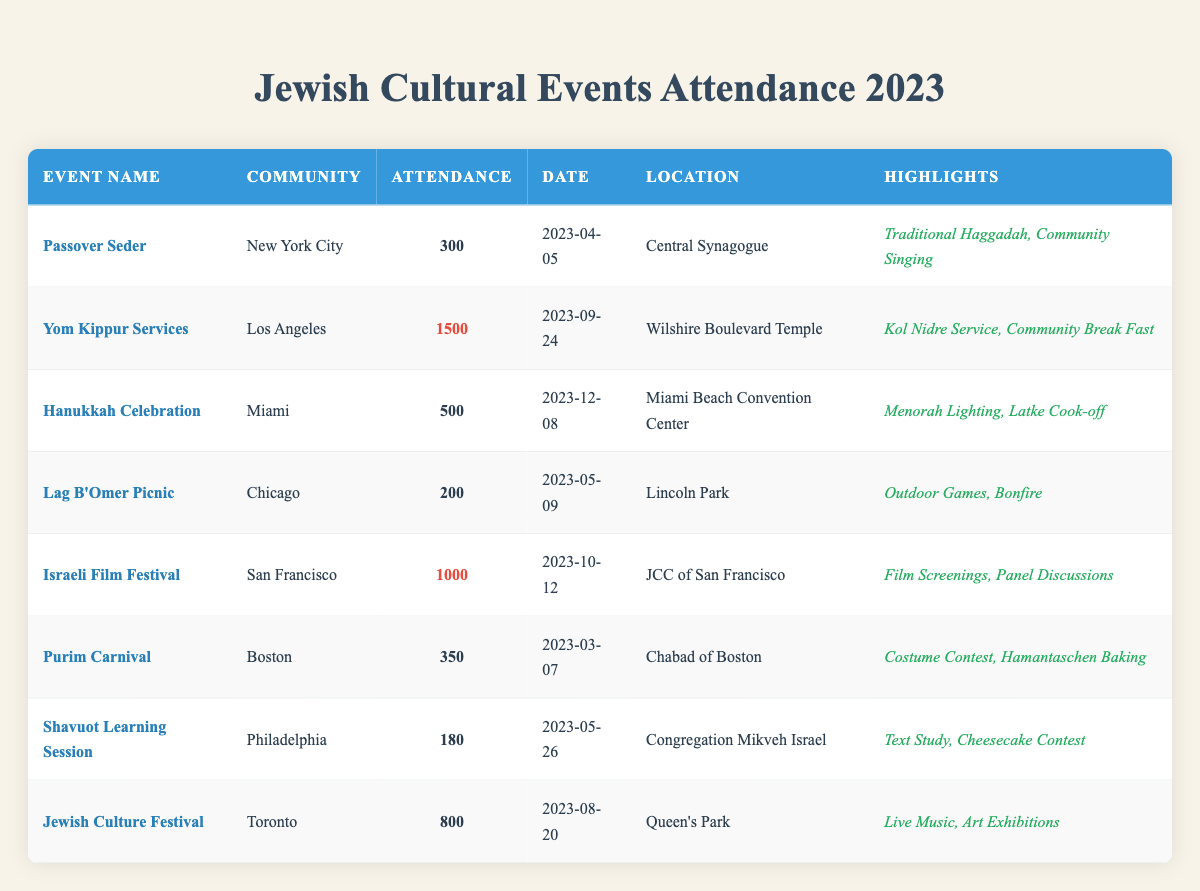What was the attendance for the Yom Kippur Services? The table shows that the attendance for the Yom Kippur Services held in Los Angeles was 1500.
Answer: 1500 Which community had the lowest attendance at a cultural event? By comparing the attendance numbers across all events, the Lag B'Omer Picnic in Chicago had the lowest at 200.
Answer: Chicago What is the total attendance for all events listed? The total attendance can be calculated by adding all attendance figures: 300 + 1500 + 500 + 200 + 1000 + 350 + 180 + 800 = 3830.
Answer: 3830 How many events had an attendance of more than 600? The events with attendance over 600 are Yom Kippur Services (1500), Israeli Film Festival (1000), and Jewish Culture Festival (800), totaling three events.
Answer: 3 Was the Hanukkah Celebration attended by more people than the Purim Carnival? The attendance for the Hanukkah Celebration was 500 while the Purim Carnival had 350, so yes, Hanukkah Celebration had a higher attendance.
Answer: Yes What is the average attendance for the cultural events? To find the average, sum the attendance (3830) and divide by the number of events (8): 3830 / 8 = 478.75, rounded down is 478.
Answer: 478 How many events were held in the month of May? The table indicates that two events were held in May: Lag B'Omer Picnic and Shavuot Learning Session.
Answer: 2 Which event had the highest attendance, and what was the date? Yom Kippur Services had the highest attendance at 1500, which took place on 2023-09-24.
Answer: 1500 on 2023-09-24 What is the difference in attendance between the Hanukkah Celebration and the Shavuot Learning Session? The attendance difference is calculated as follows: 500 (Hanukkah) - 180 (Shavuot) = 320.
Answer: 320 Was the attendance for the Jewish Culture Festival less than that of Passover Seder? The Jewish Culture Festival had an attendance of 800, which is greater than the Passover Seder's attendance of 300, so the statement is false.
Answer: No 